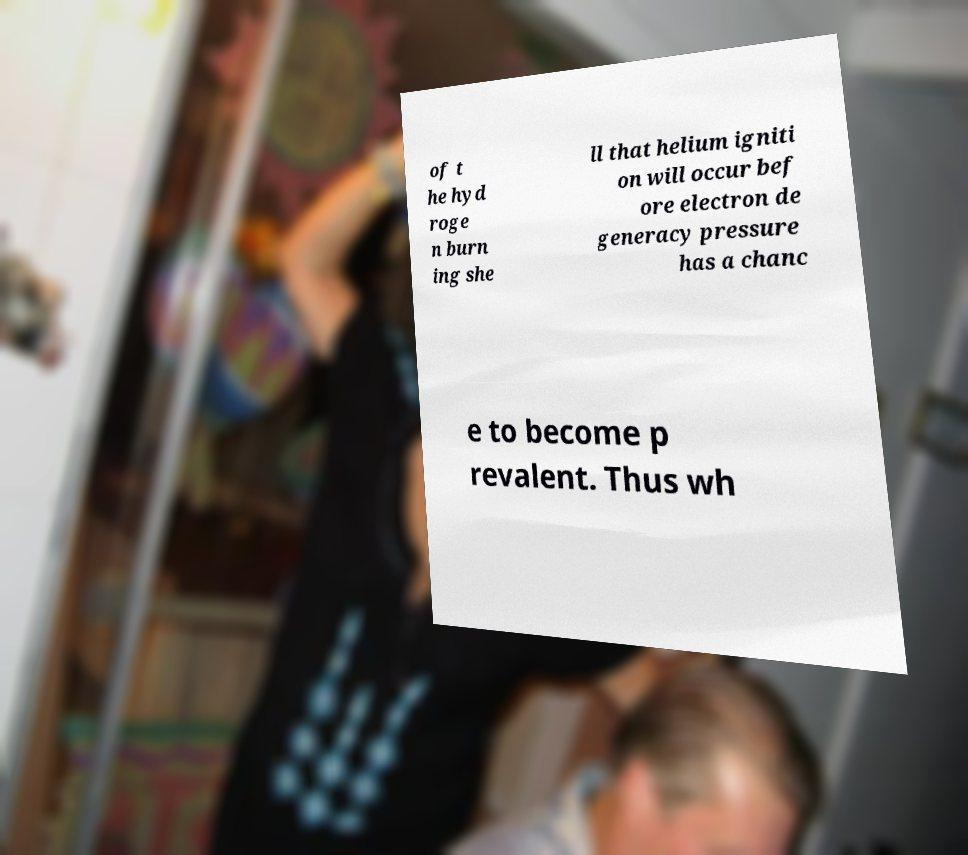There's text embedded in this image that I need extracted. Can you transcribe it verbatim? of t he hyd roge n burn ing she ll that helium igniti on will occur bef ore electron de generacy pressure has a chanc e to become p revalent. Thus wh 